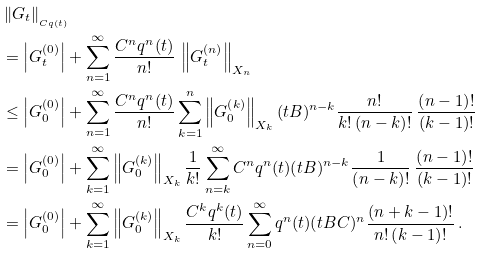Convert formula to latex. <formula><loc_0><loc_0><loc_500><loc_500>& \left \| G _ { t } \right \| _ { \L _ { C q ( t ) } } \\ & = \left | G _ { t } ^ { \left ( 0 \right ) } \right | + \sum _ { n = 1 } ^ { \infty } \frac { C ^ { n } q ^ { n } ( t ) } { n ! } \, \left \| G _ { t } ^ { \left ( n \right ) } \right \| _ { X _ { n } } \\ & \leq \left | G _ { 0 } ^ { \left ( 0 \right ) } \right | + \sum _ { n = 1 } ^ { \infty } \frac { C ^ { n } q ^ { n } ( t ) } { n ! } \sum _ { k = 1 } ^ { n } \left \| G _ { 0 } ^ { \left ( k \right ) } \right \| _ { X _ { k } } ( t B ) ^ { n - k } \frac { n ! } { k ! \left ( n - k \right ) ! } \, \frac { \left ( n - 1 \right ) ! } { \left ( k - 1 \right ) ! } \\ & = \left | G _ { 0 } ^ { \left ( 0 \right ) } \right | + \sum _ { k = 1 } ^ { \infty } \left \| G _ { 0 } ^ { \left ( k \right ) } \right \| _ { X _ { k } } \frac { 1 } { k ! } \sum _ { n = k } ^ { \infty } C ^ { n } q ^ { n } ( t ) ( t B ) ^ { n - k } \frac { 1 } { \left ( n - k \right ) ! } \, \frac { \left ( n - 1 \right ) ! } { \left ( k - 1 \right ) ! } \\ & = \left | G _ { 0 } ^ { \left ( 0 \right ) } \right | + \sum _ { k = 1 } ^ { \infty } \left \| G _ { 0 } ^ { \left ( k \right ) } \right \| _ { X _ { k } } \frac { C ^ { k } q ^ { k } ( t ) } { k ! } \sum _ { n = 0 } ^ { \infty } q ^ { n } ( t ) ( t B C ) ^ { n } \frac { \left ( n + k - 1 \right ) ! } { n ! \left ( k - 1 \right ) ! } \, .</formula> 